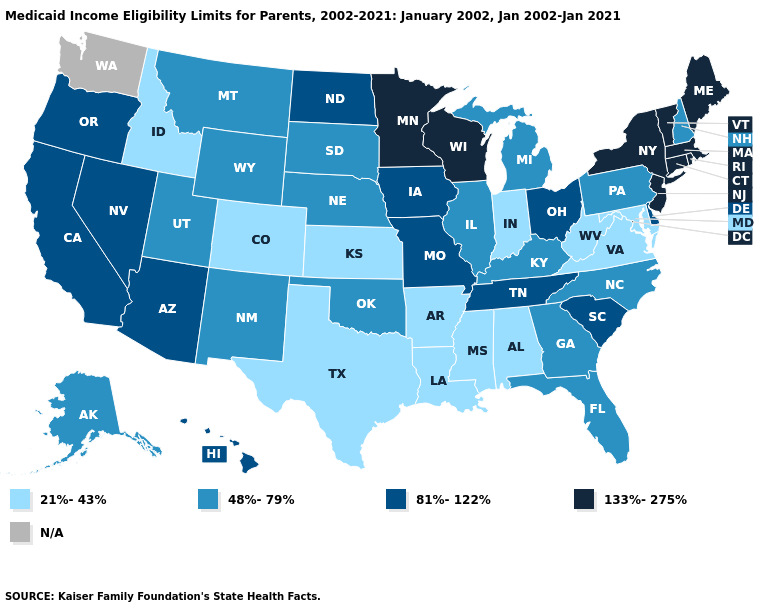What is the value of West Virginia?
Write a very short answer. 21%-43%. What is the highest value in states that border New Hampshire?
Quick response, please. 133%-275%. Does Alaska have the highest value in the West?
Quick response, please. No. What is the value of Maine?
Keep it brief. 133%-275%. What is the highest value in the USA?
Write a very short answer. 133%-275%. What is the lowest value in states that border Mississippi?
Keep it brief. 21%-43%. What is the value of Montana?
Keep it brief. 48%-79%. Name the states that have a value in the range 133%-275%?
Short answer required. Connecticut, Maine, Massachusetts, Minnesota, New Jersey, New York, Rhode Island, Vermont, Wisconsin. Name the states that have a value in the range 81%-122%?
Concise answer only. Arizona, California, Delaware, Hawaii, Iowa, Missouri, Nevada, North Dakota, Ohio, Oregon, South Carolina, Tennessee. Name the states that have a value in the range 21%-43%?
Keep it brief. Alabama, Arkansas, Colorado, Idaho, Indiana, Kansas, Louisiana, Maryland, Mississippi, Texas, Virginia, West Virginia. What is the highest value in the South ?
Give a very brief answer. 81%-122%. What is the value of Indiana?
Give a very brief answer. 21%-43%. What is the lowest value in states that border West Virginia?
Write a very short answer. 21%-43%. Name the states that have a value in the range 81%-122%?
Short answer required. Arizona, California, Delaware, Hawaii, Iowa, Missouri, Nevada, North Dakota, Ohio, Oregon, South Carolina, Tennessee. 